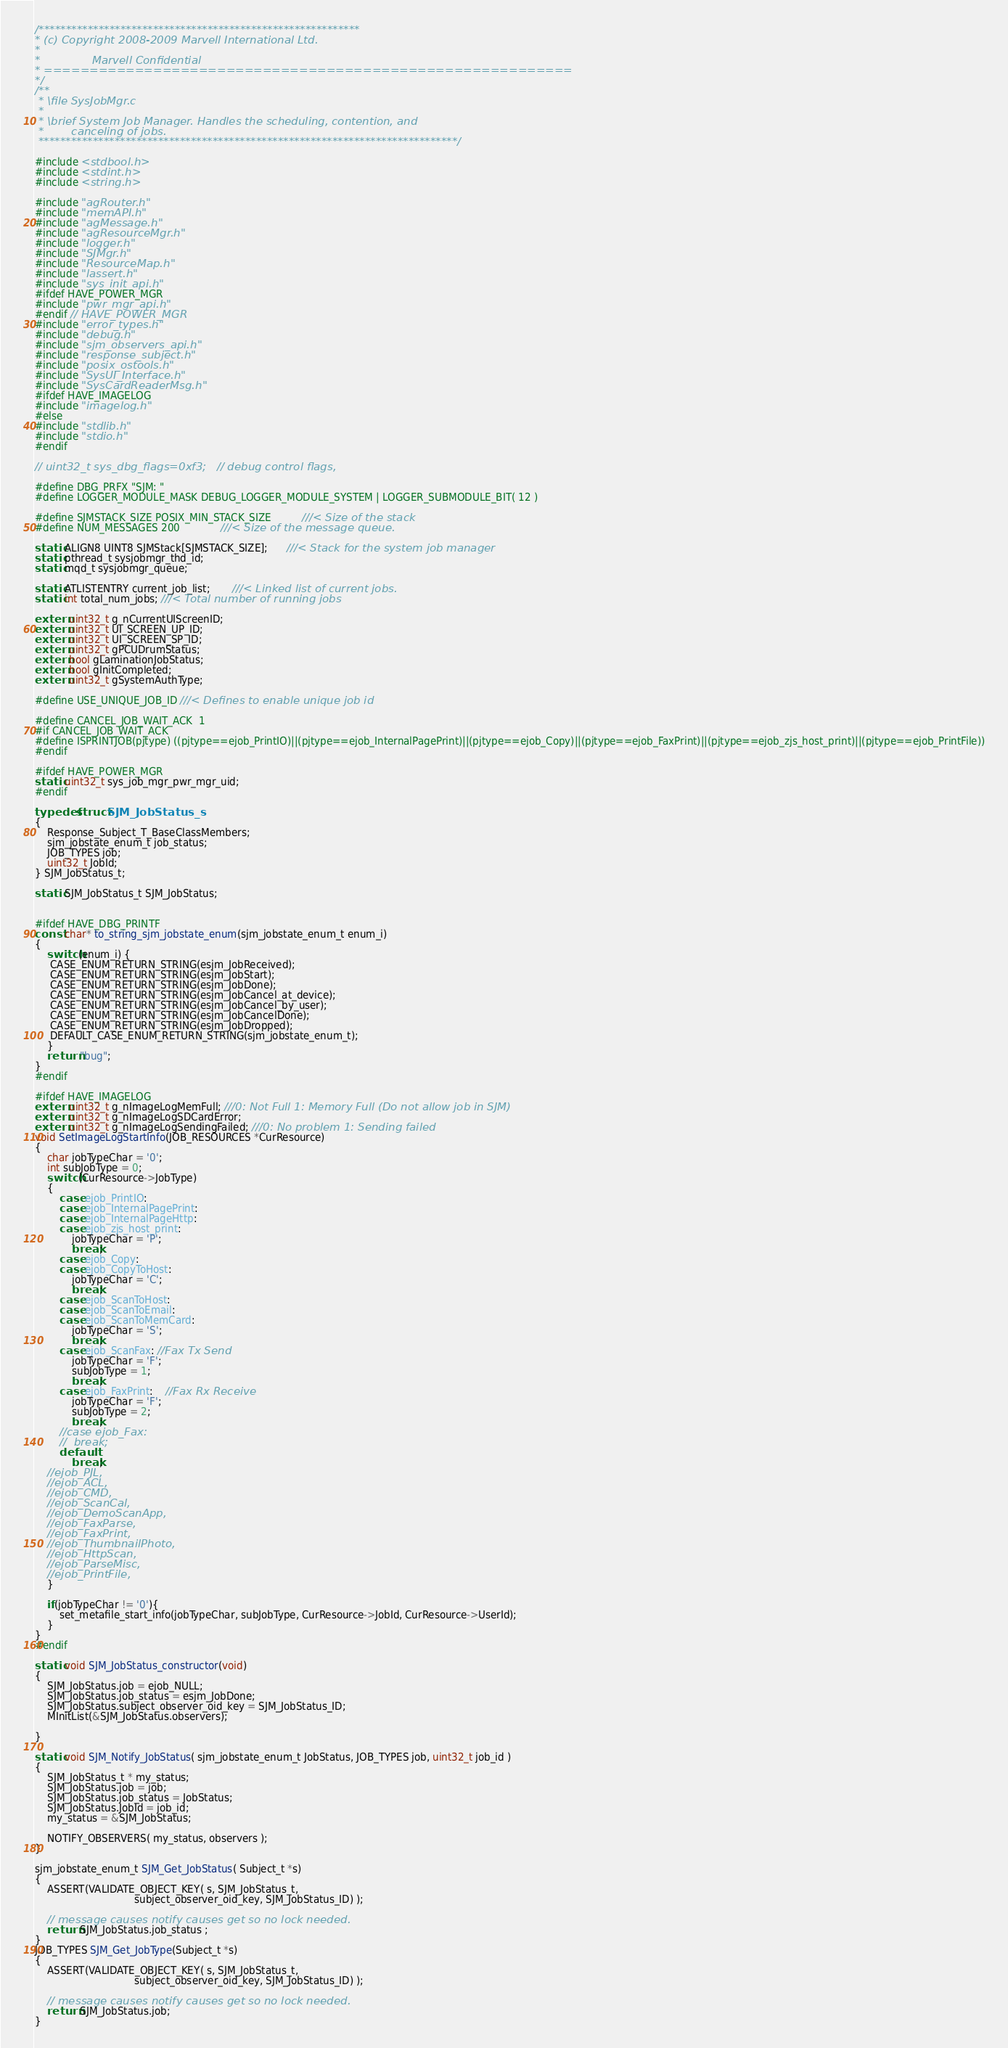Convert code to text. <code><loc_0><loc_0><loc_500><loc_500><_C_>/***********************************************************
* (c) Copyright 2008-2009 Marvell International Ltd. 
*
*               Marvell Confidential
* ==========================================================
*/
/**
 * \file SysJobMgr.c
 *
 * \brief System Job Manager. Handles the scheduling, contention, and
 *        canceling of jobs.
 *****************************************************************************/
 
#include <stdbool.h>
#include <stdint.h>
#include <string.h>

#include "agRouter.h"
#include "memAPI.h"
#include "agMessage.h"
#include "agResourceMgr.h"
#include "logger.h"
#include "SJMgr.h"
#include "ResourceMap.h"
#include "lassert.h"
#include "sys_init_api.h"
#ifdef HAVE_POWER_MGR
#include "pwr_mgr_api.h"
#endif // HAVE_POWER_MGR
#include "error_types.h"
#include "debug.h"
#include "sjm_observers_api.h"
#include "response_subject.h"
#include "posix_ostools.h"
#include "SysUI_Interface.h"
#include "SysCardReaderMsg.h"
#ifdef HAVE_IMAGELOG
#include "imagelog.h"
#else
#include "stdlib.h"
#include "stdio.h"
#endif

// uint32_t sys_dbg_flags=0xf3;   // debug control flags, 

#define DBG_PRFX "SJM: "
#define LOGGER_MODULE_MASK DEBUG_LOGGER_MODULE_SYSTEM | LOGGER_SUBMODULE_BIT( 12 ) 

#define SJMSTACK_SIZE POSIX_MIN_STACK_SIZE          ///< Size of the stack
#define NUM_MESSAGES 200             ///< Size of the message queue.

static ALIGN8 UINT8 SJMStack[SJMSTACK_SIZE];      ///< Stack for the system job manager
static pthread_t sysjobmgr_thd_id;
static mqd_t sysjobmgr_queue;

static ATLISTENTRY current_job_list;       ///< Linked list of current jobs.
static int total_num_jobs; ///< Total number of running jobs 

extern uint32_t g_nCurrentUIScreenID;
extern uint32_t UI_SCREEN_UP_ID;
extern uint32_t UI_SCREEN_SP_ID;
extern uint32_t gPCUDrumStatus;
extern bool gLaminationJobStatus;
extern bool gInitCompleted;
extern uint32_t gSystemAuthType;

#define USE_UNIQUE_JOB_ID ///< Defines to enable unique job id

#define CANCEL_JOB_WAIT_ACK	1
#if CANCEL_JOB_WAIT_ACK
#define ISPRINTJOB(pjtype) ((pjtype==ejob_PrintIO)||(pjtype==ejob_InternalPagePrint)||(pjtype==ejob_Copy)||(pjtype==ejob_FaxPrint)||(pjtype==ejob_zjs_host_print)||(pjtype==ejob_PrintFile))
#endif

#ifdef HAVE_POWER_MGR
static uint32_t sys_job_mgr_pwr_mgr_uid;
#endif

typedef struct SJM_JobStatus_s
{
    Response_Subject_T_BaseClassMembers;
    sjm_jobstate_enum_t job_status;
    JOB_TYPES job;
    uint32_t JobId;
} SJM_JobStatus_t;

static SJM_JobStatus_t SJM_JobStatus;


#ifdef HAVE_DBG_PRINTF
const char* to_string_sjm_jobstate_enum(sjm_jobstate_enum_t enum_i)
{
    switch(enum_i) {
	 CASE_ENUM_RETURN_STRING(esjm_JobReceived);
	 CASE_ENUM_RETURN_STRING(esjm_JobStart);
	 CASE_ENUM_RETURN_STRING(esjm_JobDone);
	 CASE_ENUM_RETURN_STRING(esjm_JobCancel_at_device);
	 CASE_ENUM_RETURN_STRING(esjm_JobCancel_by_user);
	 CASE_ENUM_RETURN_STRING(esjm_JobCancelDone);
	 CASE_ENUM_RETURN_STRING(esjm_JobDropped);
	 DEFAULT_CASE_ENUM_RETURN_STRING(sjm_jobstate_enum_t);
    }
    return "bug";
} 
#endif

#ifdef HAVE_IMAGELOG
extern uint32_t g_nImageLogMemFull; ///0: Not Full 1: Memory Full (Do not allow job in SJM)
extern uint32_t g_nImageLogSDCardError;
extern uint32_t g_nImageLogSendingFailed; ///0: No problem 1: Sending failed
void SetImageLogStartInfo(JOB_RESOURCES *CurResource)
{
	char jobTypeChar = '0';
	int subJobType = 0;
	switch(CurResource->JobType)
	{
		case ejob_PrintIO:
		case ejob_InternalPagePrint:
		case ejob_InternalPageHttp:
		case ejob_zjs_host_print:
			jobTypeChar = 'P';
			break;
		case ejob_Copy:
		case ejob_CopyToHost:
			jobTypeChar = 'C';
			break;
		case ejob_ScanToHost:
		case ejob_ScanToEmail:
		case ejob_ScanToMemCard:
			jobTypeChar = 'S';
			break;
		case ejob_ScanFax: //Fax Tx Send
			jobTypeChar = 'F';
			subJobType = 1;
			break;
		case ejob_FaxPrint:	//Fax Rx Receive
			jobTypeChar = 'F';
			subJobType = 2;
			break;
		//case ejob_Fax:
		//	break;
		default:
			break;
	//ejob_PJL,
	//ejob_ACL,
	//ejob_CMD,
	//ejob_ScanCal,
	//ejob_DemoScanApp,
	//ejob_FaxParse,
	//ejob_FaxPrint,
	//ejob_ThumbnailPhoto,
	//ejob_HttpScan,
	//ejob_ParseMisc,
	//ejob_PrintFile,
	}

	if(jobTypeChar != '0'){
		set_metafile_start_info(jobTypeChar, subJobType, CurResource->JobId, CurResource->UserId);
	}
}
#endif

static void SJM_JobStatus_constructor(void)
{
    SJM_JobStatus.job = ejob_NULL;
    SJM_JobStatus.job_status = esjm_JobDone;
    SJM_JobStatus.subject_observer_oid_key = SJM_JobStatus_ID;
    MInitList(&SJM_JobStatus.observers);

}

static void SJM_Notify_JobStatus( sjm_jobstate_enum_t JobStatus, JOB_TYPES job, uint32_t job_id )
{
    SJM_JobStatus_t * my_status;
    SJM_JobStatus.job = job;
    SJM_JobStatus.job_status = JobStatus;
    SJM_JobStatus.JobId = job_id;
    my_status = &SJM_JobStatus;

    NOTIFY_OBSERVERS( my_status, observers );
}

sjm_jobstate_enum_t SJM_Get_JobStatus( Subject_t *s)
{
    ASSERT(VALIDATE_OBJECT_KEY( s, SJM_JobStatus_t, 
                                subject_observer_oid_key, SJM_JobStatus_ID) );

    // message causes notify causes get so no lock needed. 
    return SJM_JobStatus.job_status ;
}
JOB_TYPES SJM_Get_JobType(Subject_t *s)
{
    ASSERT(VALIDATE_OBJECT_KEY( s, SJM_JobStatus_t, 
                                subject_observer_oid_key, SJM_JobStatus_ID) );

    // message causes notify causes get so no lock needed. 
    return SJM_JobStatus.job;
}</code> 